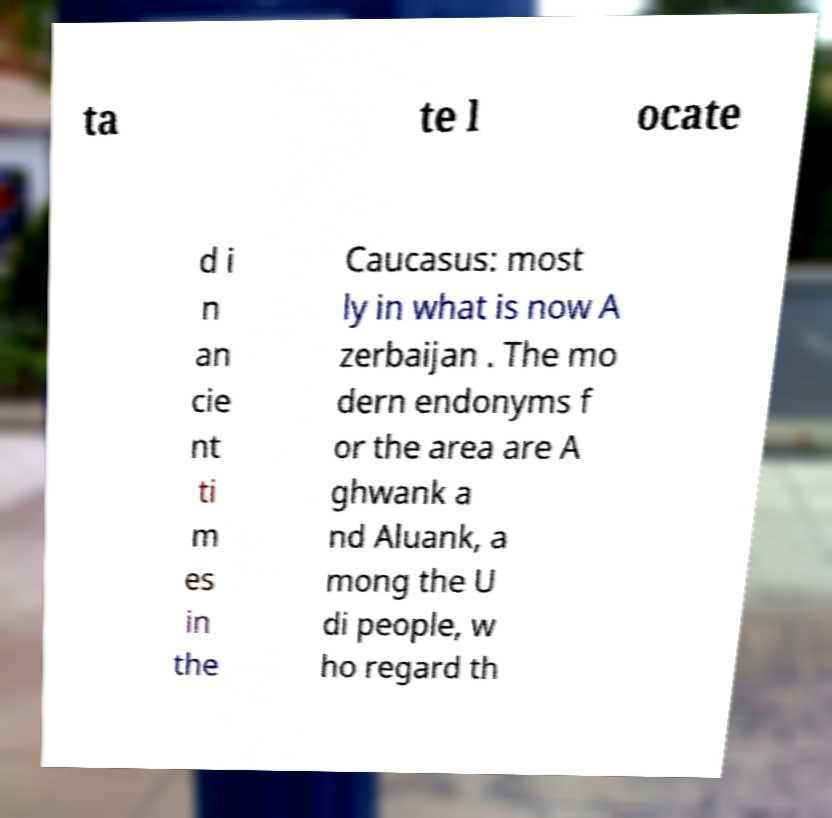Can you accurately transcribe the text from the provided image for me? ta te l ocate d i n an cie nt ti m es in the Caucasus: most ly in what is now A zerbaijan . The mo dern endonyms f or the area are A ghwank a nd Aluank, a mong the U di people, w ho regard th 